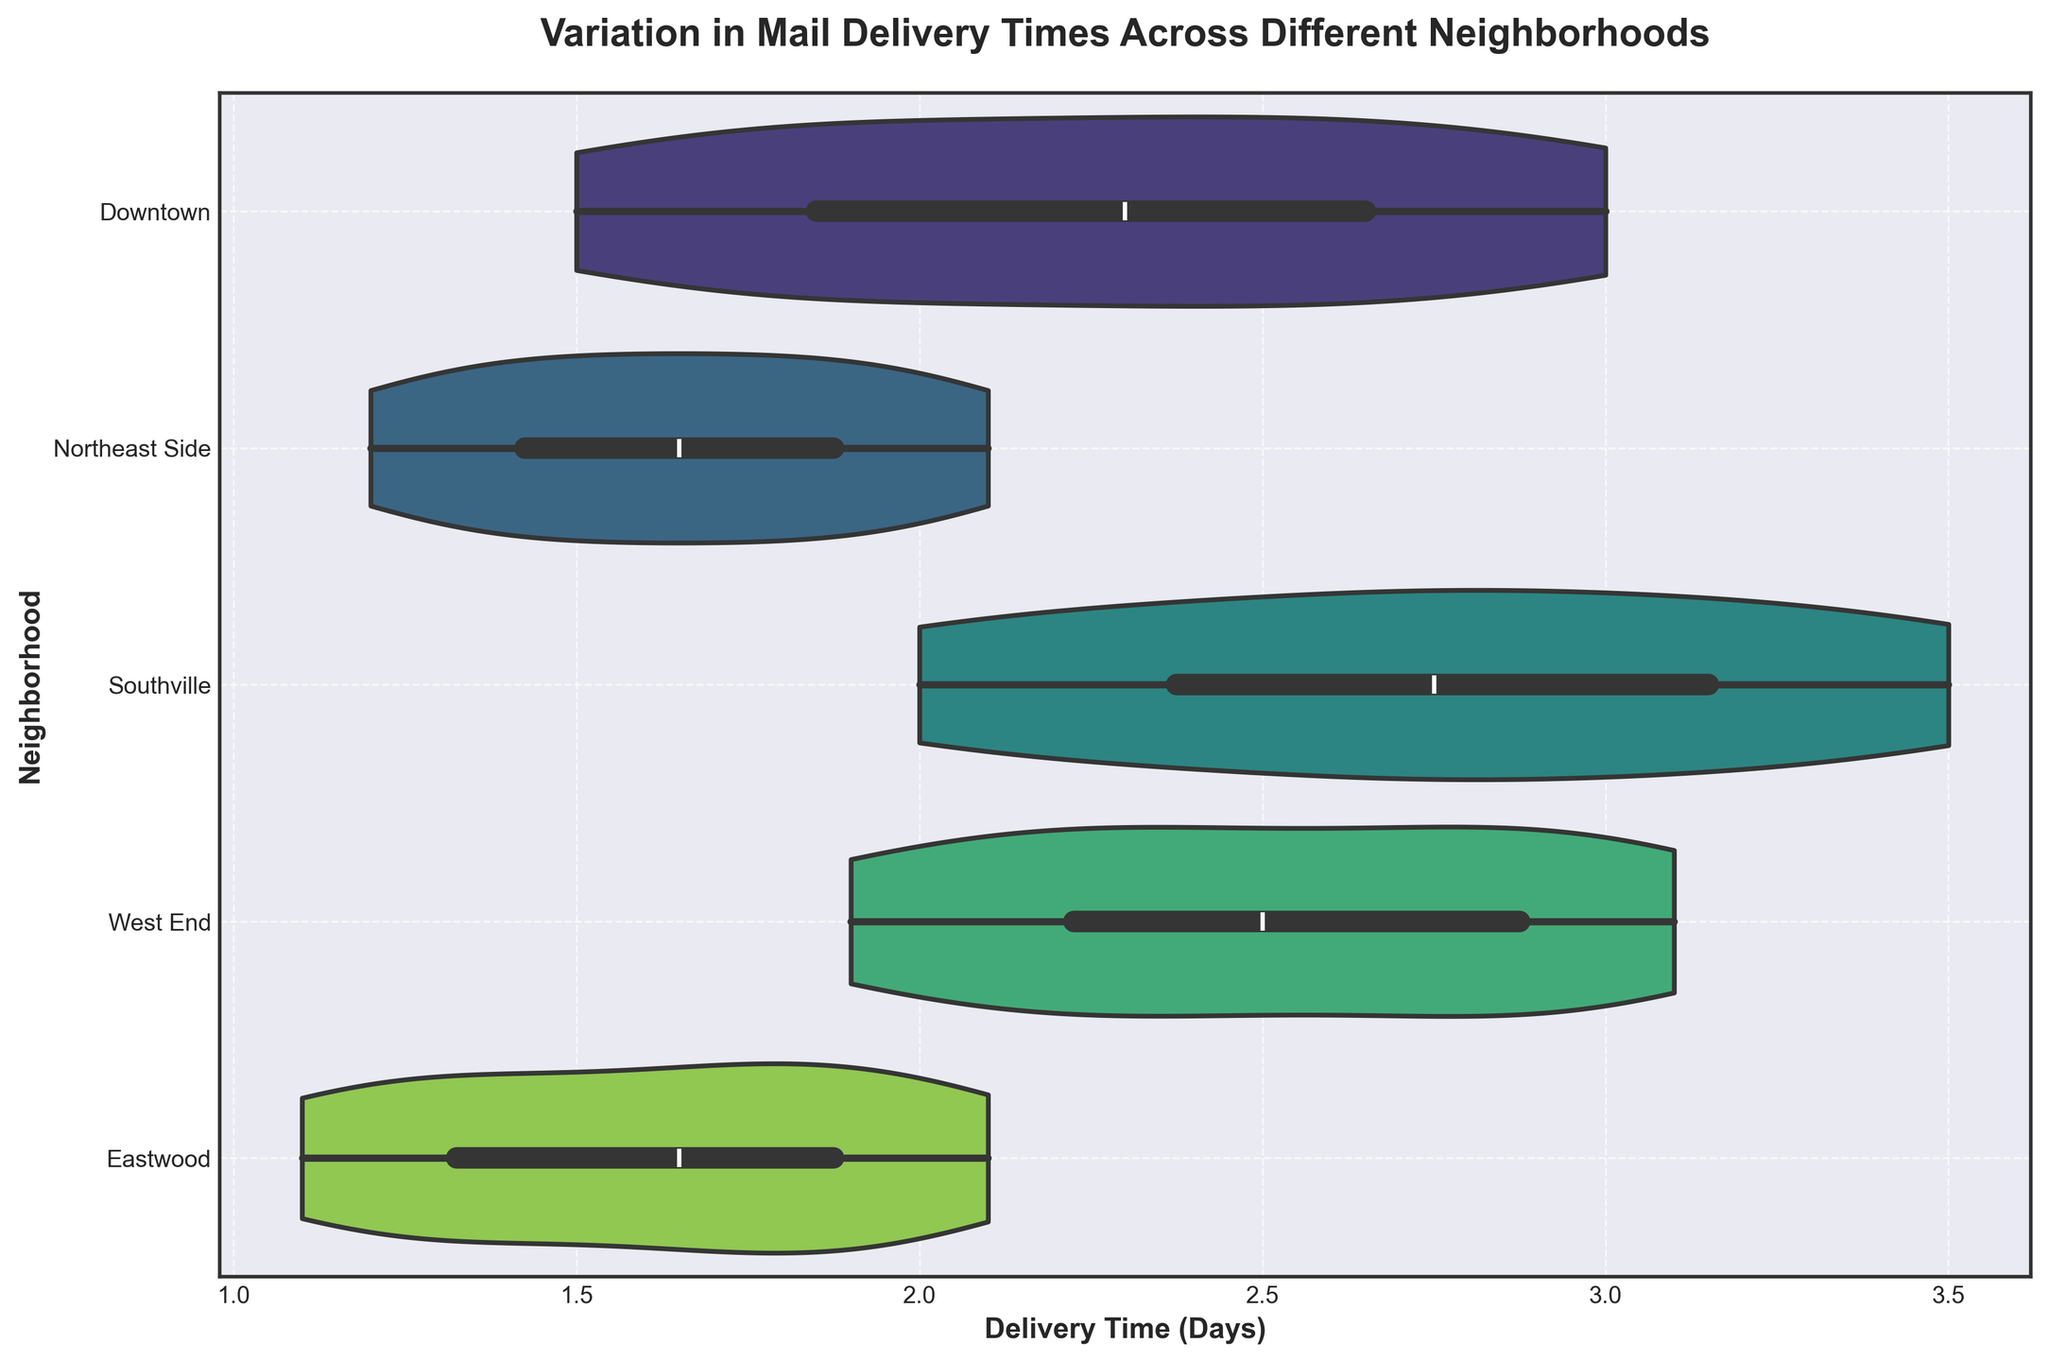What's the title of the figure? The title is prominently displayed at the top of the figure, which describes the main subject of the plot.
Answer: Variation in Mail Delivery Times Across Different Neighborhoods What are the labels for the x-axis and y-axis? The labels for the axes are found along the respective dimensions and explain what the axes represent.
Answer: Delivery Time (Days) and Neighborhood Which neighborhood has the highest median delivery time? To determine this, we look at the central line within each violin plot that represents the median.
Answer: Southville Which neighborhood has the lowest variability in mail delivery times? The neighborhood with the narrowest shape of the violin plot along the x-axis shows the least variability.
Answer: Northeast Side How does the range of delivery times in Downtown compare to Eastwood? Compare the spread of the delivery times (width of the violin plots) for both neighborhoods.
Answer: Downtown has a wider range than Eastwood Which neighborhood has the widest distribution of delivery times? The neighborhood with the widest spread (violin plot) along the x-axis indicates the most variability.
Answer: Southville What is the approximate range of delivery times in the West End? Check the extent of the violin plot along the x-axis for West End.
Answer: 1.9 to 3.1 days Is the median delivery time in Downtown greater than that in Eastwood? Compare the position of the median lines inside the violin plots for both neighborhoods.
Answer: Yes Which neighborhood's delivery times are the most skewed, and in which direction? Skew is observed by the shape of the violin plot, whether it's more extended towards the higher or lower delivery times.
Answer: Downtown, skewed towards higher delivery times Which two neighborhoods have the most similar median delivery times? Identify neighborhoods with median lines at similar positions within the violin plots.
Answer: West End and Northeast Side 